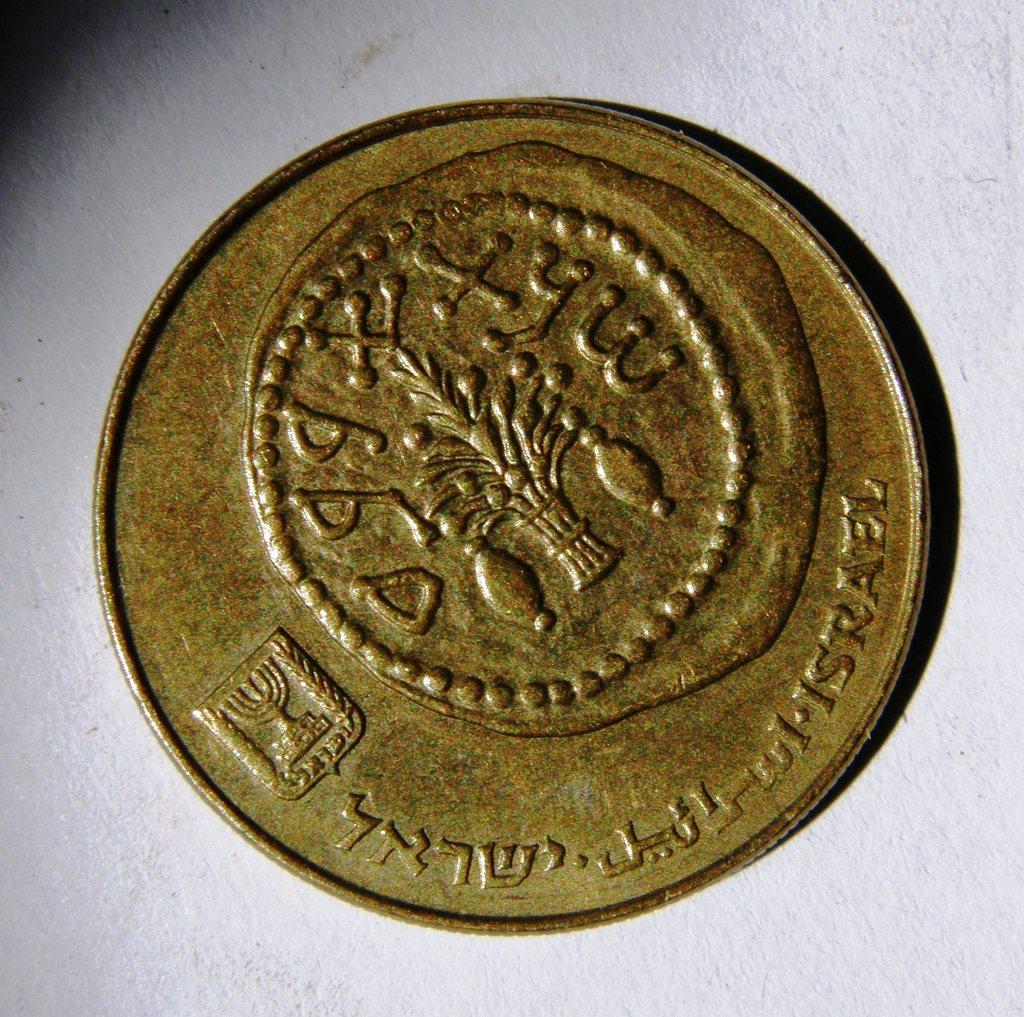<image>
Describe the image concisely. a long word on a coin that is from a different language 